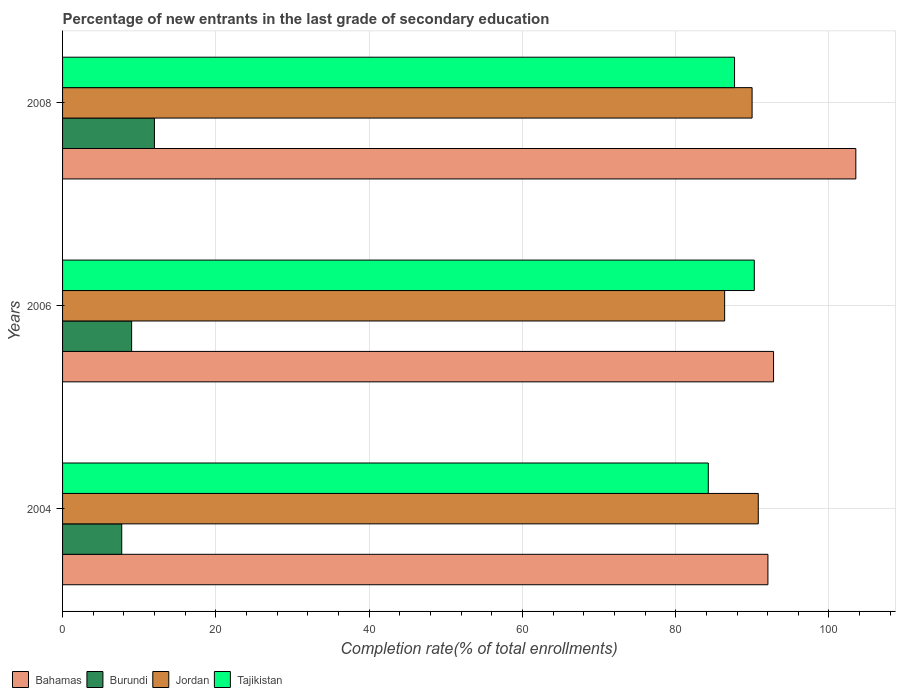Are the number of bars per tick equal to the number of legend labels?
Keep it short and to the point. Yes. Are the number of bars on each tick of the Y-axis equal?
Your answer should be very brief. Yes. How many bars are there on the 1st tick from the top?
Your response must be concise. 4. How many bars are there on the 3rd tick from the bottom?
Make the answer very short. 4. What is the label of the 1st group of bars from the top?
Keep it short and to the point. 2008. What is the percentage of new entrants in Tajikistan in 2004?
Provide a succinct answer. 84.25. Across all years, what is the maximum percentage of new entrants in Bahamas?
Ensure brevity in your answer.  103.5. Across all years, what is the minimum percentage of new entrants in Tajikistan?
Your answer should be compact. 84.25. In which year was the percentage of new entrants in Bahamas minimum?
Your answer should be compact. 2004. What is the total percentage of new entrants in Bahamas in the graph?
Make the answer very short. 288.31. What is the difference between the percentage of new entrants in Bahamas in 2004 and that in 2008?
Offer a terse response. -11.47. What is the difference between the percentage of new entrants in Jordan in 2004 and the percentage of new entrants in Tajikistan in 2008?
Provide a succinct answer. 3.1. What is the average percentage of new entrants in Tajikistan per year?
Ensure brevity in your answer.  87.4. In the year 2006, what is the difference between the percentage of new entrants in Tajikistan and percentage of new entrants in Burundi?
Your response must be concise. 81.25. What is the ratio of the percentage of new entrants in Tajikistan in 2004 to that in 2006?
Ensure brevity in your answer.  0.93. Is the difference between the percentage of new entrants in Tajikistan in 2006 and 2008 greater than the difference between the percentage of new entrants in Burundi in 2006 and 2008?
Make the answer very short. Yes. What is the difference between the highest and the second highest percentage of new entrants in Jordan?
Ensure brevity in your answer.  0.81. What is the difference between the highest and the lowest percentage of new entrants in Burundi?
Offer a very short reply. 4.26. In how many years, is the percentage of new entrants in Burundi greater than the average percentage of new entrants in Burundi taken over all years?
Provide a short and direct response. 1. Is the sum of the percentage of new entrants in Jordan in 2004 and 2006 greater than the maximum percentage of new entrants in Bahamas across all years?
Your response must be concise. Yes. Is it the case that in every year, the sum of the percentage of new entrants in Tajikistan and percentage of new entrants in Jordan is greater than the sum of percentage of new entrants in Bahamas and percentage of new entrants in Burundi?
Provide a succinct answer. Yes. What does the 1st bar from the top in 2004 represents?
Provide a succinct answer. Tajikistan. What does the 4th bar from the bottom in 2006 represents?
Offer a very short reply. Tajikistan. How many bars are there?
Offer a very short reply. 12. How many years are there in the graph?
Keep it short and to the point. 3. Does the graph contain any zero values?
Your response must be concise. No. What is the title of the graph?
Offer a terse response. Percentage of new entrants in the last grade of secondary education. What is the label or title of the X-axis?
Ensure brevity in your answer.  Completion rate(% of total enrollments). What is the Completion rate(% of total enrollments) in Bahamas in 2004?
Offer a very short reply. 92.03. What is the Completion rate(% of total enrollments) in Burundi in 2004?
Provide a short and direct response. 7.72. What is the Completion rate(% of total enrollments) in Jordan in 2004?
Give a very brief answer. 90.78. What is the Completion rate(% of total enrollments) of Tajikistan in 2004?
Give a very brief answer. 84.25. What is the Completion rate(% of total enrollments) in Bahamas in 2006?
Keep it short and to the point. 92.77. What is the Completion rate(% of total enrollments) of Burundi in 2006?
Offer a terse response. 9.01. What is the Completion rate(% of total enrollments) of Jordan in 2006?
Make the answer very short. 86.39. What is the Completion rate(% of total enrollments) of Tajikistan in 2006?
Make the answer very short. 90.26. What is the Completion rate(% of total enrollments) of Bahamas in 2008?
Make the answer very short. 103.5. What is the Completion rate(% of total enrollments) of Burundi in 2008?
Offer a very short reply. 11.98. What is the Completion rate(% of total enrollments) in Jordan in 2008?
Keep it short and to the point. 89.97. What is the Completion rate(% of total enrollments) of Tajikistan in 2008?
Ensure brevity in your answer.  87.68. Across all years, what is the maximum Completion rate(% of total enrollments) in Bahamas?
Offer a terse response. 103.5. Across all years, what is the maximum Completion rate(% of total enrollments) of Burundi?
Ensure brevity in your answer.  11.98. Across all years, what is the maximum Completion rate(% of total enrollments) in Jordan?
Your answer should be compact. 90.78. Across all years, what is the maximum Completion rate(% of total enrollments) in Tajikistan?
Your answer should be very brief. 90.26. Across all years, what is the minimum Completion rate(% of total enrollments) of Bahamas?
Your response must be concise. 92.03. Across all years, what is the minimum Completion rate(% of total enrollments) of Burundi?
Make the answer very short. 7.72. Across all years, what is the minimum Completion rate(% of total enrollments) in Jordan?
Provide a succinct answer. 86.39. Across all years, what is the minimum Completion rate(% of total enrollments) in Tajikistan?
Give a very brief answer. 84.25. What is the total Completion rate(% of total enrollments) of Bahamas in the graph?
Your response must be concise. 288.31. What is the total Completion rate(% of total enrollments) of Burundi in the graph?
Offer a very short reply. 28.71. What is the total Completion rate(% of total enrollments) of Jordan in the graph?
Offer a terse response. 267.13. What is the total Completion rate(% of total enrollments) in Tajikistan in the graph?
Your answer should be very brief. 262.19. What is the difference between the Completion rate(% of total enrollments) of Bahamas in 2004 and that in 2006?
Give a very brief answer. -0.73. What is the difference between the Completion rate(% of total enrollments) in Burundi in 2004 and that in 2006?
Offer a very short reply. -1.29. What is the difference between the Completion rate(% of total enrollments) of Jordan in 2004 and that in 2006?
Your answer should be compact. 4.39. What is the difference between the Completion rate(% of total enrollments) in Tajikistan in 2004 and that in 2006?
Give a very brief answer. -6. What is the difference between the Completion rate(% of total enrollments) of Bahamas in 2004 and that in 2008?
Offer a very short reply. -11.47. What is the difference between the Completion rate(% of total enrollments) in Burundi in 2004 and that in 2008?
Give a very brief answer. -4.26. What is the difference between the Completion rate(% of total enrollments) in Jordan in 2004 and that in 2008?
Give a very brief answer. 0.81. What is the difference between the Completion rate(% of total enrollments) of Tajikistan in 2004 and that in 2008?
Make the answer very short. -3.43. What is the difference between the Completion rate(% of total enrollments) in Bahamas in 2006 and that in 2008?
Offer a very short reply. -10.73. What is the difference between the Completion rate(% of total enrollments) in Burundi in 2006 and that in 2008?
Provide a succinct answer. -2.97. What is the difference between the Completion rate(% of total enrollments) of Jordan in 2006 and that in 2008?
Provide a short and direct response. -3.58. What is the difference between the Completion rate(% of total enrollments) in Tajikistan in 2006 and that in 2008?
Give a very brief answer. 2.58. What is the difference between the Completion rate(% of total enrollments) of Bahamas in 2004 and the Completion rate(% of total enrollments) of Burundi in 2006?
Provide a succinct answer. 83.02. What is the difference between the Completion rate(% of total enrollments) in Bahamas in 2004 and the Completion rate(% of total enrollments) in Jordan in 2006?
Your answer should be very brief. 5.65. What is the difference between the Completion rate(% of total enrollments) of Bahamas in 2004 and the Completion rate(% of total enrollments) of Tajikistan in 2006?
Make the answer very short. 1.78. What is the difference between the Completion rate(% of total enrollments) in Burundi in 2004 and the Completion rate(% of total enrollments) in Jordan in 2006?
Offer a terse response. -78.67. What is the difference between the Completion rate(% of total enrollments) in Burundi in 2004 and the Completion rate(% of total enrollments) in Tajikistan in 2006?
Ensure brevity in your answer.  -82.54. What is the difference between the Completion rate(% of total enrollments) in Jordan in 2004 and the Completion rate(% of total enrollments) in Tajikistan in 2006?
Offer a very short reply. 0.52. What is the difference between the Completion rate(% of total enrollments) of Bahamas in 2004 and the Completion rate(% of total enrollments) of Burundi in 2008?
Ensure brevity in your answer.  80.05. What is the difference between the Completion rate(% of total enrollments) in Bahamas in 2004 and the Completion rate(% of total enrollments) in Jordan in 2008?
Keep it short and to the point. 2.07. What is the difference between the Completion rate(% of total enrollments) in Bahamas in 2004 and the Completion rate(% of total enrollments) in Tajikistan in 2008?
Offer a very short reply. 4.36. What is the difference between the Completion rate(% of total enrollments) in Burundi in 2004 and the Completion rate(% of total enrollments) in Jordan in 2008?
Keep it short and to the point. -82.25. What is the difference between the Completion rate(% of total enrollments) in Burundi in 2004 and the Completion rate(% of total enrollments) in Tajikistan in 2008?
Provide a succinct answer. -79.96. What is the difference between the Completion rate(% of total enrollments) in Jordan in 2004 and the Completion rate(% of total enrollments) in Tajikistan in 2008?
Your response must be concise. 3.1. What is the difference between the Completion rate(% of total enrollments) in Bahamas in 2006 and the Completion rate(% of total enrollments) in Burundi in 2008?
Keep it short and to the point. 80.79. What is the difference between the Completion rate(% of total enrollments) in Bahamas in 2006 and the Completion rate(% of total enrollments) in Jordan in 2008?
Provide a succinct answer. 2.8. What is the difference between the Completion rate(% of total enrollments) of Bahamas in 2006 and the Completion rate(% of total enrollments) of Tajikistan in 2008?
Your answer should be compact. 5.09. What is the difference between the Completion rate(% of total enrollments) in Burundi in 2006 and the Completion rate(% of total enrollments) in Jordan in 2008?
Offer a very short reply. -80.96. What is the difference between the Completion rate(% of total enrollments) of Burundi in 2006 and the Completion rate(% of total enrollments) of Tajikistan in 2008?
Give a very brief answer. -78.67. What is the difference between the Completion rate(% of total enrollments) in Jordan in 2006 and the Completion rate(% of total enrollments) in Tajikistan in 2008?
Ensure brevity in your answer.  -1.29. What is the average Completion rate(% of total enrollments) of Bahamas per year?
Provide a short and direct response. 96.1. What is the average Completion rate(% of total enrollments) in Burundi per year?
Offer a very short reply. 9.57. What is the average Completion rate(% of total enrollments) of Jordan per year?
Make the answer very short. 89.04. What is the average Completion rate(% of total enrollments) of Tajikistan per year?
Offer a terse response. 87.4. In the year 2004, what is the difference between the Completion rate(% of total enrollments) in Bahamas and Completion rate(% of total enrollments) in Burundi?
Ensure brevity in your answer.  84.31. In the year 2004, what is the difference between the Completion rate(% of total enrollments) of Bahamas and Completion rate(% of total enrollments) of Jordan?
Your answer should be compact. 1.26. In the year 2004, what is the difference between the Completion rate(% of total enrollments) in Bahamas and Completion rate(% of total enrollments) in Tajikistan?
Make the answer very short. 7.78. In the year 2004, what is the difference between the Completion rate(% of total enrollments) of Burundi and Completion rate(% of total enrollments) of Jordan?
Ensure brevity in your answer.  -83.06. In the year 2004, what is the difference between the Completion rate(% of total enrollments) in Burundi and Completion rate(% of total enrollments) in Tajikistan?
Your answer should be compact. -76.53. In the year 2004, what is the difference between the Completion rate(% of total enrollments) of Jordan and Completion rate(% of total enrollments) of Tajikistan?
Offer a terse response. 6.52. In the year 2006, what is the difference between the Completion rate(% of total enrollments) of Bahamas and Completion rate(% of total enrollments) of Burundi?
Offer a very short reply. 83.76. In the year 2006, what is the difference between the Completion rate(% of total enrollments) in Bahamas and Completion rate(% of total enrollments) in Jordan?
Keep it short and to the point. 6.38. In the year 2006, what is the difference between the Completion rate(% of total enrollments) of Bahamas and Completion rate(% of total enrollments) of Tajikistan?
Give a very brief answer. 2.51. In the year 2006, what is the difference between the Completion rate(% of total enrollments) in Burundi and Completion rate(% of total enrollments) in Jordan?
Offer a very short reply. -77.38. In the year 2006, what is the difference between the Completion rate(% of total enrollments) in Burundi and Completion rate(% of total enrollments) in Tajikistan?
Ensure brevity in your answer.  -81.25. In the year 2006, what is the difference between the Completion rate(% of total enrollments) in Jordan and Completion rate(% of total enrollments) in Tajikistan?
Keep it short and to the point. -3.87. In the year 2008, what is the difference between the Completion rate(% of total enrollments) of Bahamas and Completion rate(% of total enrollments) of Burundi?
Make the answer very short. 91.52. In the year 2008, what is the difference between the Completion rate(% of total enrollments) of Bahamas and Completion rate(% of total enrollments) of Jordan?
Your answer should be compact. 13.54. In the year 2008, what is the difference between the Completion rate(% of total enrollments) in Bahamas and Completion rate(% of total enrollments) in Tajikistan?
Your answer should be compact. 15.83. In the year 2008, what is the difference between the Completion rate(% of total enrollments) in Burundi and Completion rate(% of total enrollments) in Jordan?
Your response must be concise. -77.98. In the year 2008, what is the difference between the Completion rate(% of total enrollments) of Burundi and Completion rate(% of total enrollments) of Tajikistan?
Offer a very short reply. -75.69. In the year 2008, what is the difference between the Completion rate(% of total enrollments) in Jordan and Completion rate(% of total enrollments) in Tajikistan?
Your answer should be very brief. 2.29. What is the ratio of the Completion rate(% of total enrollments) of Bahamas in 2004 to that in 2006?
Give a very brief answer. 0.99. What is the ratio of the Completion rate(% of total enrollments) in Burundi in 2004 to that in 2006?
Offer a terse response. 0.86. What is the ratio of the Completion rate(% of total enrollments) in Jordan in 2004 to that in 2006?
Your answer should be very brief. 1.05. What is the ratio of the Completion rate(% of total enrollments) in Tajikistan in 2004 to that in 2006?
Offer a terse response. 0.93. What is the ratio of the Completion rate(% of total enrollments) in Bahamas in 2004 to that in 2008?
Your response must be concise. 0.89. What is the ratio of the Completion rate(% of total enrollments) of Burundi in 2004 to that in 2008?
Make the answer very short. 0.64. What is the ratio of the Completion rate(% of total enrollments) in Jordan in 2004 to that in 2008?
Your answer should be very brief. 1.01. What is the ratio of the Completion rate(% of total enrollments) of Tajikistan in 2004 to that in 2008?
Give a very brief answer. 0.96. What is the ratio of the Completion rate(% of total enrollments) in Bahamas in 2006 to that in 2008?
Provide a short and direct response. 0.9. What is the ratio of the Completion rate(% of total enrollments) of Burundi in 2006 to that in 2008?
Your answer should be compact. 0.75. What is the ratio of the Completion rate(% of total enrollments) in Jordan in 2006 to that in 2008?
Give a very brief answer. 0.96. What is the ratio of the Completion rate(% of total enrollments) of Tajikistan in 2006 to that in 2008?
Your response must be concise. 1.03. What is the difference between the highest and the second highest Completion rate(% of total enrollments) of Bahamas?
Provide a succinct answer. 10.73. What is the difference between the highest and the second highest Completion rate(% of total enrollments) in Burundi?
Offer a very short reply. 2.97. What is the difference between the highest and the second highest Completion rate(% of total enrollments) in Jordan?
Your answer should be compact. 0.81. What is the difference between the highest and the second highest Completion rate(% of total enrollments) of Tajikistan?
Your response must be concise. 2.58. What is the difference between the highest and the lowest Completion rate(% of total enrollments) in Bahamas?
Your answer should be compact. 11.47. What is the difference between the highest and the lowest Completion rate(% of total enrollments) in Burundi?
Keep it short and to the point. 4.26. What is the difference between the highest and the lowest Completion rate(% of total enrollments) of Jordan?
Give a very brief answer. 4.39. What is the difference between the highest and the lowest Completion rate(% of total enrollments) in Tajikistan?
Provide a short and direct response. 6. 